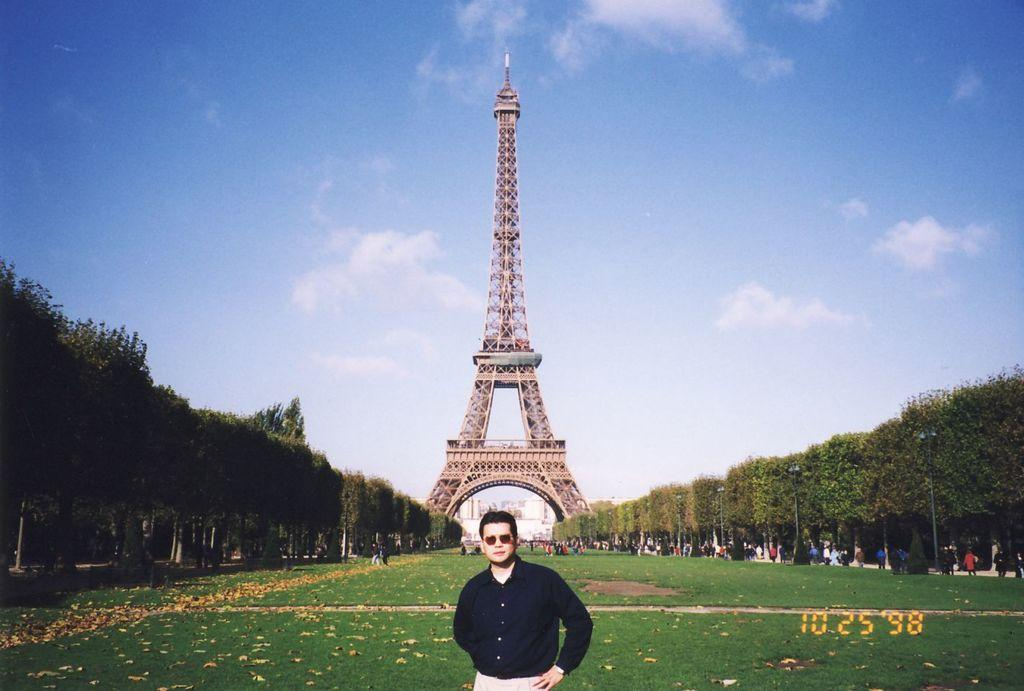Who or what is the main subject in the image? There is a person in the image. What is the person wearing? The person is wearing a black shirt. What is the person doing in the image? The person is standing. What can be seen in the background of the image? There are trees on either side of the person. Are there any other people in the image? Yes, there are other persons standing in the right corner of the image. What type of coach can be seen in the image? There is no coach present in the image. What is the pump used for in the image? There is no pump present in the image. 